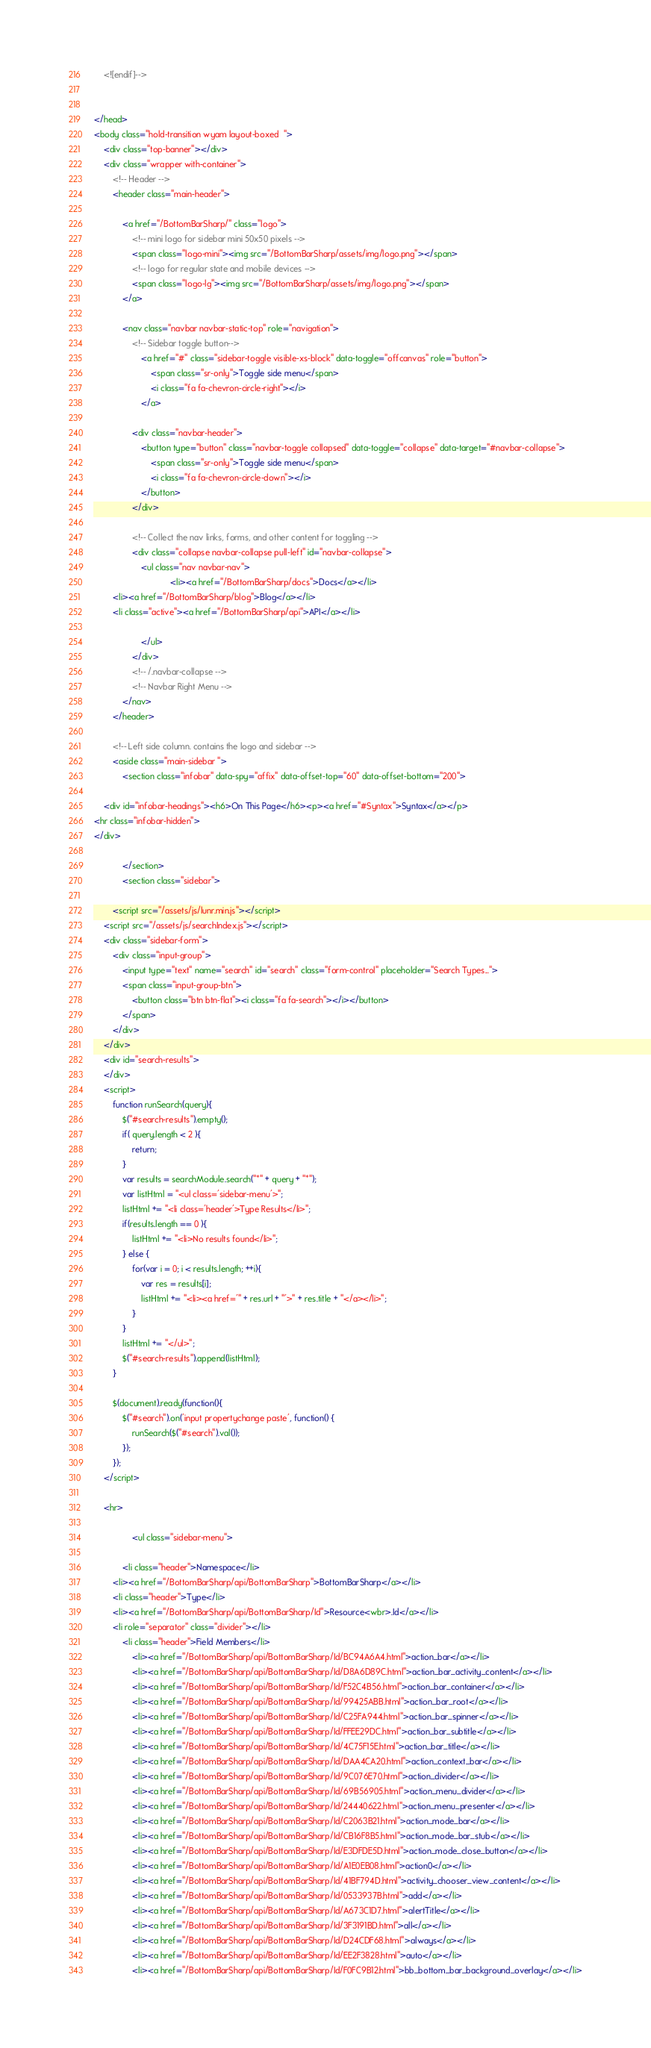<code> <loc_0><loc_0><loc_500><loc_500><_HTML_>    <![endif]-->

    
</head>
<body class="hold-transition wyam layout-boxed  ">
    <div class="top-banner"></div>
    <div class="wrapper with-container">
        <!-- Header -->
        <header class="main-header">

            <a href="/BottomBarSharp/" class="logo">
                <!-- mini logo for sidebar mini 50x50 pixels -->
                <span class="logo-mini"><img src="/BottomBarSharp/assets/img/logo.png"></span>
                <!-- logo for regular state and mobile devices -->
                <span class="logo-lg"><img src="/BottomBarSharp/assets/img/logo.png"></span>
            </a>

            <nav class="navbar navbar-static-top" role="navigation">
                <!-- Sidebar toggle button-->
                    <a href="#" class="sidebar-toggle visible-xs-block" data-toggle="offcanvas" role="button">
                        <span class="sr-only">Toggle side menu</span>
                        <i class="fa fa-chevron-circle-right"></i>
                    </a>

                <div class="navbar-header">
                    <button type="button" class="navbar-toggle collapsed" data-toggle="collapse" data-target="#navbar-collapse">
                        <span class="sr-only">Toggle side menu</span>
                        <i class="fa fa-chevron-circle-down"></i>
                    </button>
                </div>

                <!-- Collect the nav links, forms, and other content for toggling -->
                <div class="collapse navbar-collapse pull-left" id="navbar-collapse">
                    <ul class="nav navbar-nav">
                                <li><a href="/BottomBarSharp/docs">Docs</a></li>
        <li><a href="/BottomBarSharp/blog">Blog</a></li>
        <li class="active"><a href="/BottomBarSharp/api">API</a></li>

                    </ul>
                </div>
                <!-- /.navbar-collapse -->
                <!-- Navbar Right Menu -->
            </nav>
        </header>

        <!-- Left side column. contains the logo and sidebar -->
        <aside class="main-sidebar ">
            <section class="infobar" data-spy="affix" data-offset-top="60" data-offset-bottom="200">
                	
	<div id="infobar-headings"><h6>On This Page</h6><p><a href="#Syntax">Syntax</a></p>
<hr class="infobar-hidden">
</div>

            </section>
            <section class="sidebar">
                	
	    <script src="/assets/js/lunr.min.js"></script>
    <script src="/assets/js/searchIndex.js"></script>
    <div class="sidebar-form">
        <div class="input-group">
            <input type="text" name="search" id="search" class="form-control" placeholder="Search Types...">
            <span class="input-group-btn">
                <button class="btn btn-flat"><i class="fa fa-search"></i></button>
            </span>
        </div>
    </div>
    <div id="search-results">
    </div>
    <script>
        function runSearch(query){
            $("#search-results").empty();			
            if( query.length < 2 ){
                return;
            }			
            var results = searchModule.search("*" + query + "*");
            var listHtml = "<ul class='sidebar-menu'>";	
            listHtml += "<li class='header'>Type Results</li>";	
            if(results.length == 0 ){
                listHtml += "<li>No results found</li>";
            } else {					
                for(var i = 0; i < results.length; ++i){
                    var res = results[i];
                    listHtml += "<li><a href='" + res.url + "'>" + res.title + "</a></li>";
                }				
            }
            listHtml += "</ul>";				
            $("#search-results").append(listHtml);
        }

        $(document).ready(function(){
            $("#search").on('input propertychange paste', function() {
                runSearch($("#search").val());
            });
        });
    </script>
	
    <hr>

                <ul class="sidebar-menu">
                    
			<li class="header">Namespace</li>
		<li><a href="/BottomBarSharp/api/BottomBarSharp">BottomBarSharp</a></li>
		<li class="header">Type</li>
		<li><a href="/BottomBarSharp/api/BottomBarSharp/Id">Resource<wbr>.Id</a></li>
		<li role="separator" class="divider"></li>
			<li class="header">Field Members</li>
				<li><a href="/BottomBarSharp/api/BottomBarSharp/Id/BC94A6A4.html">action_bar</a></li>
				<li><a href="/BottomBarSharp/api/BottomBarSharp/Id/D8A6D89C.html">action_bar_activity_content</a></li>
				<li><a href="/BottomBarSharp/api/BottomBarSharp/Id/F52C4B56.html">action_bar_container</a></li>
				<li><a href="/BottomBarSharp/api/BottomBarSharp/Id/99425ABB.html">action_bar_root</a></li>
				<li><a href="/BottomBarSharp/api/BottomBarSharp/Id/C25FA944.html">action_bar_spinner</a></li>
				<li><a href="/BottomBarSharp/api/BottomBarSharp/Id/FFEE29DC.html">action_bar_subtitle</a></li>
				<li><a href="/BottomBarSharp/api/BottomBarSharp/Id/4C75F15E.html">action_bar_title</a></li>
				<li><a href="/BottomBarSharp/api/BottomBarSharp/Id/DAA4CA20.html">action_context_bar</a></li>
				<li><a href="/BottomBarSharp/api/BottomBarSharp/Id/9C076E70.html">action_divider</a></li>
				<li><a href="/BottomBarSharp/api/BottomBarSharp/Id/69B56905.html">action_menu_divider</a></li>
				<li><a href="/BottomBarSharp/api/BottomBarSharp/Id/24440622.html">action_menu_presenter</a></li>
				<li><a href="/BottomBarSharp/api/BottomBarSharp/Id/C2063B21.html">action_mode_bar</a></li>
				<li><a href="/BottomBarSharp/api/BottomBarSharp/Id/CB16F8B5.html">action_mode_bar_stub</a></li>
				<li><a href="/BottomBarSharp/api/BottomBarSharp/Id/E3DFDE5D.html">action_mode_close_button</a></li>
				<li><a href="/BottomBarSharp/api/BottomBarSharp/Id/A1E0EB08.html">action0</a></li>
				<li><a href="/BottomBarSharp/api/BottomBarSharp/Id/41BF794D.html">activity_chooser_view_content</a></li>
				<li><a href="/BottomBarSharp/api/BottomBarSharp/Id/0533937B.html">add</a></li>
				<li><a href="/BottomBarSharp/api/BottomBarSharp/Id/A673C1D7.html">alertTitle</a></li>
				<li><a href="/BottomBarSharp/api/BottomBarSharp/Id/3F3191BD.html">all</a></li>
				<li><a href="/BottomBarSharp/api/BottomBarSharp/Id/D24CDF68.html">always</a></li>
				<li><a href="/BottomBarSharp/api/BottomBarSharp/Id/EE2F3828.html">auto</a></li>
				<li><a href="/BottomBarSharp/api/BottomBarSharp/Id/F0FC9B12.html">bb_bottom_bar_background_overlay</a></li></code> 